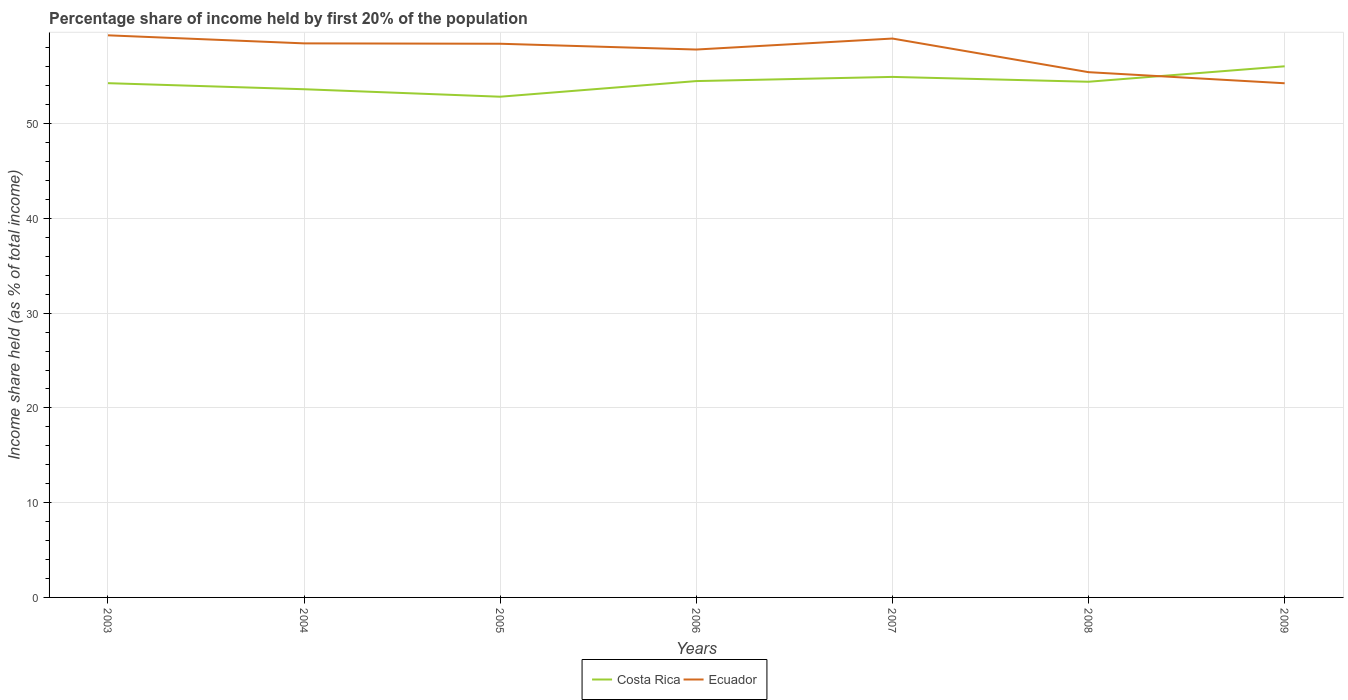How many different coloured lines are there?
Your answer should be compact. 2. Across all years, what is the maximum share of income held by first 20% of the population in Ecuador?
Ensure brevity in your answer.  54.27. What is the total share of income held by first 20% of the population in Costa Rica in the graph?
Ensure brevity in your answer.  0.51. What is the difference between the highest and the second highest share of income held by first 20% of the population in Ecuador?
Keep it short and to the point. 5.06. What is the difference between the highest and the lowest share of income held by first 20% of the population in Ecuador?
Keep it short and to the point. 5. How many lines are there?
Your response must be concise. 2. How many years are there in the graph?
Keep it short and to the point. 7. What is the difference between two consecutive major ticks on the Y-axis?
Keep it short and to the point. 10. Are the values on the major ticks of Y-axis written in scientific E-notation?
Keep it short and to the point. No. Does the graph contain grids?
Your response must be concise. Yes. Where does the legend appear in the graph?
Your answer should be compact. Bottom center. How many legend labels are there?
Provide a succinct answer. 2. How are the legend labels stacked?
Your response must be concise. Horizontal. What is the title of the graph?
Your answer should be very brief. Percentage share of income held by first 20% of the population. What is the label or title of the Y-axis?
Provide a succinct answer. Income share held (as % of total income). What is the Income share held (as % of total income) in Costa Rica in 2003?
Provide a short and direct response. 54.28. What is the Income share held (as % of total income) of Ecuador in 2003?
Your response must be concise. 59.33. What is the Income share held (as % of total income) of Costa Rica in 2004?
Offer a terse response. 53.64. What is the Income share held (as % of total income) of Ecuador in 2004?
Provide a short and direct response. 58.48. What is the Income share held (as % of total income) in Costa Rica in 2005?
Your response must be concise. 52.85. What is the Income share held (as % of total income) in Ecuador in 2005?
Your answer should be compact. 58.44. What is the Income share held (as % of total income) in Costa Rica in 2006?
Offer a very short reply. 54.5. What is the Income share held (as % of total income) in Ecuador in 2006?
Provide a short and direct response. 57.83. What is the Income share held (as % of total income) in Costa Rica in 2007?
Make the answer very short. 54.94. What is the Income share held (as % of total income) in Ecuador in 2007?
Make the answer very short. 58.99. What is the Income share held (as % of total income) of Costa Rica in 2008?
Offer a terse response. 54.43. What is the Income share held (as % of total income) in Ecuador in 2008?
Ensure brevity in your answer.  55.44. What is the Income share held (as % of total income) of Costa Rica in 2009?
Make the answer very short. 56.06. What is the Income share held (as % of total income) in Ecuador in 2009?
Provide a short and direct response. 54.27. Across all years, what is the maximum Income share held (as % of total income) in Costa Rica?
Keep it short and to the point. 56.06. Across all years, what is the maximum Income share held (as % of total income) in Ecuador?
Make the answer very short. 59.33. Across all years, what is the minimum Income share held (as % of total income) of Costa Rica?
Offer a very short reply. 52.85. Across all years, what is the minimum Income share held (as % of total income) in Ecuador?
Your answer should be compact. 54.27. What is the total Income share held (as % of total income) of Costa Rica in the graph?
Make the answer very short. 380.7. What is the total Income share held (as % of total income) of Ecuador in the graph?
Your response must be concise. 402.78. What is the difference between the Income share held (as % of total income) of Costa Rica in 2003 and that in 2004?
Make the answer very short. 0.64. What is the difference between the Income share held (as % of total income) of Costa Rica in 2003 and that in 2005?
Your response must be concise. 1.43. What is the difference between the Income share held (as % of total income) of Ecuador in 2003 and that in 2005?
Provide a short and direct response. 0.89. What is the difference between the Income share held (as % of total income) of Costa Rica in 2003 and that in 2006?
Offer a very short reply. -0.22. What is the difference between the Income share held (as % of total income) in Ecuador in 2003 and that in 2006?
Your answer should be compact. 1.5. What is the difference between the Income share held (as % of total income) of Costa Rica in 2003 and that in 2007?
Keep it short and to the point. -0.66. What is the difference between the Income share held (as % of total income) of Ecuador in 2003 and that in 2007?
Ensure brevity in your answer.  0.34. What is the difference between the Income share held (as % of total income) in Costa Rica in 2003 and that in 2008?
Provide a short and direct response. -0.15. What is the difference between the Income share held (as % of total income) of Ecuador in 2003 and that in 2008?
Your answer should be compact. 3.89. What is the difference between the Income share held (as % of total income) in Costa Rica in 2003 and that in 2009?
Ensure brevity in your answer.  -1.78. What is the difference between the Income share held (as % of total income) of Ecuador in 2003 and that in 2009?
Provide a short and direct response. 5.06. What is the difference between the Income share held (as % of total income) of Costa Rica in 2004 and that in 2005?
Keep it short and to the point. 0.79. What is the difference between the Income share held (as % of total income) of Ecuador in 2004 and that in 2005?
Give a very brief answer. 0.04. What is the difference between the Income share held (as % of total income) in Costa Rica in 2004 and that in 2006?
Keep it short and to the point. -0.86. What is the difference between the Income share held (as % of total income) of Ecuador in 2004 and that in 2006?
Give a very brief answer. 0.65. What is the difference between the Income share held (as % of total income) in Costa Rica in 2004 and that in 2007?
Provide a short and direct response. -1.3. What is the difference between the Income share held (as % of total income) in Ecuador in 2004 and that in 2007?
Your response must be concise. -0.51. What is the difference between the Income share held (as % of total income) of Costa Rica in 2004 and that in 2008?
Offer a very short reply. -0.79. What is the difference between the Income share held (as % of total income) of Ecuador in 2004 and that in 2008?
Ensure brevity in your answer.  3.04. What is the difference between the Income share held (as % of total income) of Costa Rica in 2004 and that in 2009?
Your response must be concise. -2.42. What is the difference between the Income share held (as % of total income) of Ecuador in 2004 and that in 2009?
Your answer should be very brief. 4.21. What is the difference between the Income share held (as % of total income) of Costa Rica in 2005 and that in 2006?
Offer a terse response. -1.65. What is the difference between the Income share held (as % of total income) of Ecuador in 2005 and that in 2006?
Your response must be concise. 0.61. What is the difference between the Income share held (as % of total income) of Costa Rica in 2005 and that in 2007?
Provide a short and direct response. -2.09. What is the difference between the Income share held (as % of total income) in Ecuador in 2005 and that in 2007?
Your answer should be compact. -0.55. What is the difference between the Income share held (as % of total income) of Costa Rica in 2005 and that in 2008?
Your answer should be very brief. -1.58. What is the difference between the Income share held (as % of total income) in Ecuador in 2005 and that in 2008?
Ensure brevity in your answer.  3. What is the difference between the Income share held (as % of total income) of Costa Rica in 2005 and that in 2009?
Provide a succinct answer. -3.21. What is the difference between the Income share held (as % of total income) in Ecuador in 2005 and that in 2009?
Provide a short and direct response. 4.17. What is the difference between the Income share held (as % of total income) in Costa Rica in 2006 and that in 2007?
Offer a very short reply. -0.44. What is the difference between the Income share held (as % of total income) in Ecuador in 2006 and that in 2007?
Provide a short and direct response. -1.16. What is the difference between the Income share held (as % of total income) in Costa Rica in 2006 and that in 2008?
Keep it short and to the point. 0.07. What is the difference between the Income share held (as % of total income) of Ecuador in 2006 and that in 2008?
Offer a very short reply. 2.39. What is the difference between the Income share held (as % of total income) in Costa Rica in 2006 and that in 2009?
Provide a succinct answer. -1.56. What is the difference between the Income share held (as % of total income) of Ecuador in 2006 and that in 2009?
Keep it short and to the point. 3.56. What is the difference between the Income share held (as % of total income) of Costa Rica in 2007 and that in 2008?
Ensure brevity in your answer.  0.51. What is the difference between the Income share held (as % of total income) in Ecuador in 2007 and that in 2008?
Ensure brevity in your answer.  3.55. What is the difference between the Income share held (as % of total income) of Costa Rica in 2007 and that in 2009?
Keep it short and to the point. -1.12. What is the difference between the Income share held (as % of total income) in Ecuador in 2007 and that in 2009?
Your answer should be compact. 4.72. What is the difference between the Income share held (as % of total income) of Costa Rica in 2008 and that in 2009?
Your answer should be very brief. -1.63. What is the difference between the Income share held (as % of total income) in Ecuador in 2008 and that in 2009?
Provide a short and direct response. 1.17. What is the difference between the Income share held (as % of total income) of Costa Rica in 2003 and the Income share held (as % of total income) of Ecuador in 2005?
Provide a short and direct response. -4.16. What is the difference between the Income share held (as % of total income) in Costa Rica in 2003 and the Income share held (as % of total income) in Ecuador in 2006?
Your response must be concise. -3.55. What is the difference between the Income share held (as % of total income) in Costa Rica in 2003 and the Income share held (as % of total income) in Ecuador in 2007?
Provide a succinct answer. -4.71. What is the difference between the Income share held (as % of total income) in Costa Rica in 2003 and the Income share held (as % of total income) in Ecuador in 2008?
Ensure brevity in your answer.  -1.16. What is the difference between the Income share held (as % of total income) in Costa Rica in 2003 and the Income share held (as % of total income) in Ecuador in 2009?
Offer a very short reply. 0.01. What is the difference between the Income share held (as % of total income) in Costa Rica in 2004 and the Income share held (as % of total income) in Ecuador in 2005?
Provide a succinct answer. -4.8. What is the difference between the Income share held (as % of total income) in Costa Rica in 2004 and the Income share held (as % of total income) in Ecuador in 2006?
Give a very brief answer. -4.19. What is the difference between the Income share held (as % of total income) of Costa Rica in 2004 and the Income share held (as % of total income) of Ecuador in 2007?
Your response must be concise. -5.35. What is the difference between the Income share held (as % of total income) in Costa Rica in 2004 and the Income share held (as % of total income) in Ecuador in 2009?
Give a very brief answer. -0.63. What is the difference between the Income share held (as % of total income) in Costa Rica in 2005 and the Income share held (as % of total income) in Ecuador in 2006?
Provide a short and direct response. -4.98. What is the difference between the Income share held (as % of total income) in Costa Rica in 2005 and the Income share held (as % of total income) in Ecuador in 2007?
Your response must be concise. -6.14. What is the difference between the Income share held (as % of total income) in Costa Rica in 2005 and the Income share held (as % of total income) in Ecuador in 2008?
Make the answer very short. -2.59. What is the difference between the Income share held (as % of total income) of Costa Rica in 2005 and the Income share held (as % of total income) of Ecuador in 2009?
Provide a short and direct response. -1.42. What is the difference between the Income share held (as % of total income) in Costa Rica in 2006 and the Income share held (as % of total income) in Ecuador in 2007?
Provide a succinct answer. -4.49. What is the difference between the Income share held (as % of total income) of Costa Rica in 2006 and the Income share held (as % of total income) of Ecuador in 2008?
Give a very brief answer. -0.94. What is the difference between the Income share held (as % of total income) of Costa Rica in 2006 and the Income share held (as % of total income) of Ecuador in 2009?
Your response must be concise. 0.23. What is the difference between the Income share held (as % of total income) in Costa Rica in 2007 and the Income share held (as % of total income) in Ecuador in 2008?
Your answer should be compact. -0.5. What is the difference between the Income share held (as % of total income) of Costa Rica in 2007 and the Income share held (as % of total income) of Ecuador in 2009?
Keep it short and to the point. 0.67. What is the difference between the Income share held (as % of total income) in Costa Rica in 2008 and the Income share held (as % of total income) in Ecuador in 2009?
Provide a short and direct response. 0.16. What is the average Income share held (as % of total income) in Costa Rica per year?
Give a very brief answer. 54.39. What is the average Income share held (as % of total income) of Ecuador per year?
Your answer should be very brief. 57.54. In the year 2003, what is the difference between the Income share held (as % of total income) in Costa Rica and Income share held (as % of total income) in Ecuador?
Your answer should be very brief. -5.05. In the year 2004, what is the difference between the Income share held (as % of total income) in Costa Rica and Income share held (as % of total income) in Ecuador?
Keep it short and to the point. -4.84. In the year 2005, what is the difference between the Income share held (as % of total income) in Costa Rica and Income share held (as % of total income) in Ecuador?
Your response must be concise. -5.59. In the year 2006, what is the difference between the Income share held (as % of total income) of Costa Rica and Income share held (as % of total income) of Ecuador?
Provide a short and direct response. -3.33. In the year 2007, what is the difference between the Income share held (as % of total income) of Costa Rica and Income share held (as % of total income) of Ecuador?
Make the answer very short. -4.05. In the year 2008, what is the difference between the Income share held (as % of total income) in Costa Rica and Income share held (as % of total income) in Ecuador?
Your answer should be very brief. -1.01. In the year 2009, what is the difference between the Income share held (as % of total income) in Costa Rica and Income share held (as % of total income) in Ecuador?
Your answer should be very brief. 1.79. What is the ratio of the Income share held (as % of total income) of Costa Rica in 2003 to that in 2004?
Offer a very short reply. 1.01. What is the ratio of the Income share held (as % of total income) in Ecuador in 2003 to that in 2004?
Offer a terse response. 1.01. What is the ratio of the Income share held (as % of total income) in Costa Rica in 2003 to that in 2005?
Your answer should be compact. 1.03. What is the ratio of the Income share held (as % of total income) of Ecuador in 2003 to that in 2005?
Give a very brief answer. 1.02. What is the ratio of the Income share held (as % of total income) in Costa Rica in 2003 to that in 2006?
Your answer should be compact. 1. What is the ratio of the Income share held (as % of total income) of Ecuador in 2003 to that in 2006?
Give a very brief answer. 1.03. What is the ratio of the Income share held (as % of total income) of Costa Rica in 2003 to that in 2007?
Make the answer very short. 0.99. What is the ratio of the Income share held (as % of total income) in Ecuador in 2003 to that in 2007?
Offer a very short reply. 1.01. What is the ratio of the Income share held (as % of total income) in Costa Rica in 2003 to that in 2008?
Your answer should be compact. 1. What is the ratio of the Income share held (as % of total income) in Ecuador in 2003 to that in 2008?
Provide a succinct answer. 1.07. What is the ratio of the Income share held (as % of total income) of Costa Rica in 2003 to that in 2009?
Provide a succinct answer. 0.97. What is the ratio of the Income share held (as % of total income) of Ecuador in 2003 to that in 2009?
Your response must be concise. 1.09. What is the ratio of the Income share held (as % of total income) of Costa Rica in 2004 to that in 2005?
Offer a terse response. 1.01. What is the ratio of the Income share held (as % of total income) in Costa Rica in 2004 to that in 2006?
Keep it short and to the point. 0.98. What is the ratio of the Income share held (as % of total income) of Ecuador in 2004 to that in 2006?
Offer a very short reply. 1.01. What is the ratio of the Income share held (as % of total income) of Costa Rica in 2004 to that in 2007?
Make the answer very short. 0.98. What is the ratio of the Income share held (as % of total income) of Costa Rica in 2004 to that in 2008?
Make the answer very short. 0.99. What is the ratio of the Income share held (as % of total income) in Ecuador in 2004 to that in 2008?
Ensure brevity in your answer.  1.05. What is the ratio of the Income share held (as % of total income) in Costa Rica in 2004 to that in 2009?
Your answer should be compact. 0.96. What is the ratio of the Income share held (as % of total income) of Ecuador in 2004 to that in 2009?
Offer a terse response. 1.08. What is the ratio of the Income share held (as % of total income) of Costa Rica in 2005 to that in 2006?
Make the answer very short. 0.97. What is the ratio of the Income share held (as % of total income) of Ecuador in 2005 to that in 2006?
Your response must be concise. 1.01. What is the ratio of the Income share held (as % of total income) of Costa Rica in 2005 to that in 2007?
Offer a very short reply. 0.96. What is the ratio of the Income share held (as % of total income) in Costa Rica in 2005 to that in 2008?
Your answer should be compact. 0.97. What is the ratio of the Income share held (as % of total income) of Ecuador in 2005 to that in 2008?
Your answer should be very brief. 1.05. What is the ratio of the Income share held (as % of total income) of Costa Rica in 2005 to that in 2009?
Your answer should be very brief. 0.94. What is the ratio of the Income share held (as % of total income) in Ecuador in 2005 to that in 2009?
Ensure brevity in your answer.  1.08. What is the ratio of the Income share held (as % of total income) in Costa Rica in 2006 to that in 2007?
Offer a terse response. 0.99. What is the ratio of the Income share held (as % of total income) in Ecuador in 2006 to that in 2007?
Make the answer very short. 0.98. What is the ratio of the Income share held (as % of total income) of Ecuador in 2006 to that in 2008?
Offer a very short reply. 1.04. What is the ratio of the Income share held (as % of total income) in Costa Rica in 2006 to that in 2009?
Ensure brevity in your answer.  0.97. What is the ratio of the Income share held (as % of total income) of Ecuador in 2006 to that in 2009?
Make the answer very short. 1.07. What is the ratio of the Income share held (as % of total income) in Costa Rica in 2007 to that in 2008?
Offer a terse response. 1.01. What is the ratio of the Income share held (as % of total income) of Ecuador in 2007 to that in 2008?
Offer a very short reply. 1.06. What is the ratio of the Income share held (as % of total income) in Costa Rica in 2007 to that in 2009?
Ensure brevity in your answer.  0.98. What is the ratio of the Income share held (as % of total income) in Ecuador in 2007 to that in 2009?
Offer a terse response. 1.09. What is the ratio of the Income share held (as % of total income) of Costa Rica in 2008 to that in 2009?
Provide a short and direct response. 0.97. What is the ratio of the Income share held (as % of total income) of Ecuador in 2008 to that in 2009?
Your response must be concise. 1.02. What is the difference between the highest and the second highest Income share held (as % of total income) in Costa Rica?
Make the answer very short. 1.12. What is the difference between the highest and the second highest Income share held (as % of total income) of Ecuador?
Give a very brief answer. 0.34. What is the difference between the highest and the lowest Income share held (as % of total income) in Costa Rica?
Make the answer very short. 3.21. What is the difference between the highest and the lowest Income share held (as % of total income) of Ecuador?
Keep it short and to the point. 5.06. 